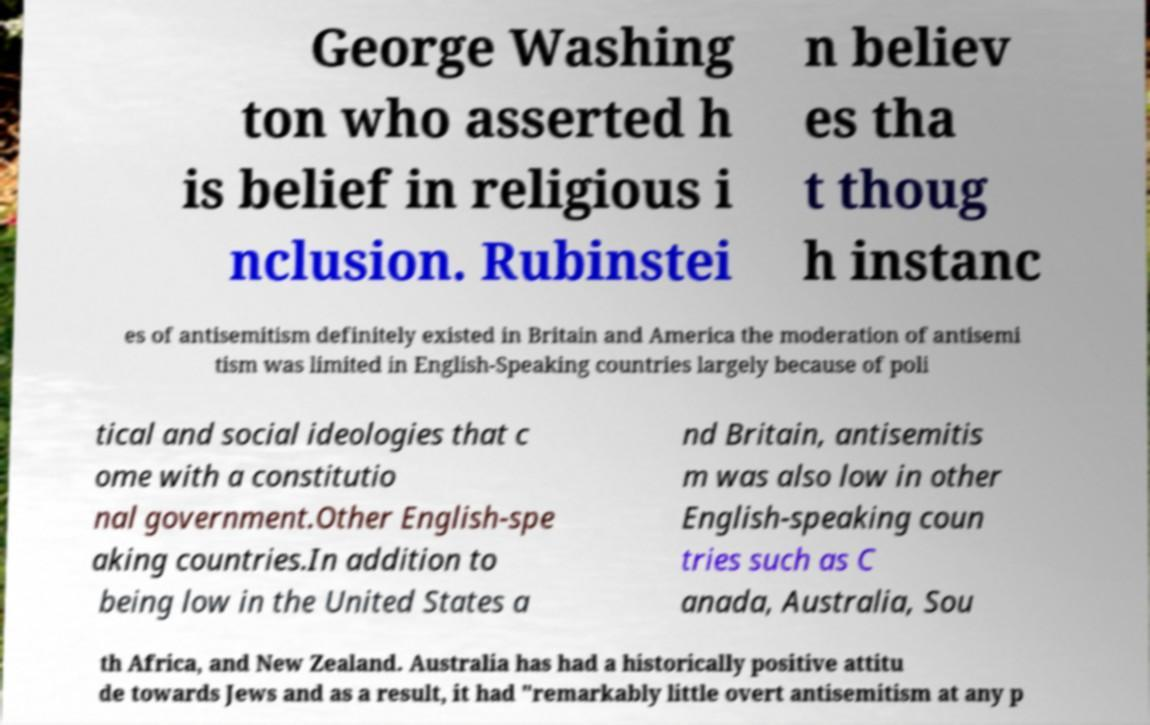Can you accurately transcribe the text from the provided image for me? George Washing ton who asserted h is belief in religious i nclusion. Rubinstei n believ es tha t thoug h instanc es of antisemitism definitely existed in Britain and America the moderation of antisemi tism was limited in English-Speaking countries largely because of poli tical and social ideologies that c ome with a constitutio nal government.Other English-spe aking countries.In addition to being low in the United States a nd Britain, antisemitis m was also low in other English-speaking coun tries such as C anada, Australia, Sou th Africa, and New Zealand. Australia has had a historically positive attitu de towards Jews and as a result, it had "remarkably little overt antisemitism at any p 